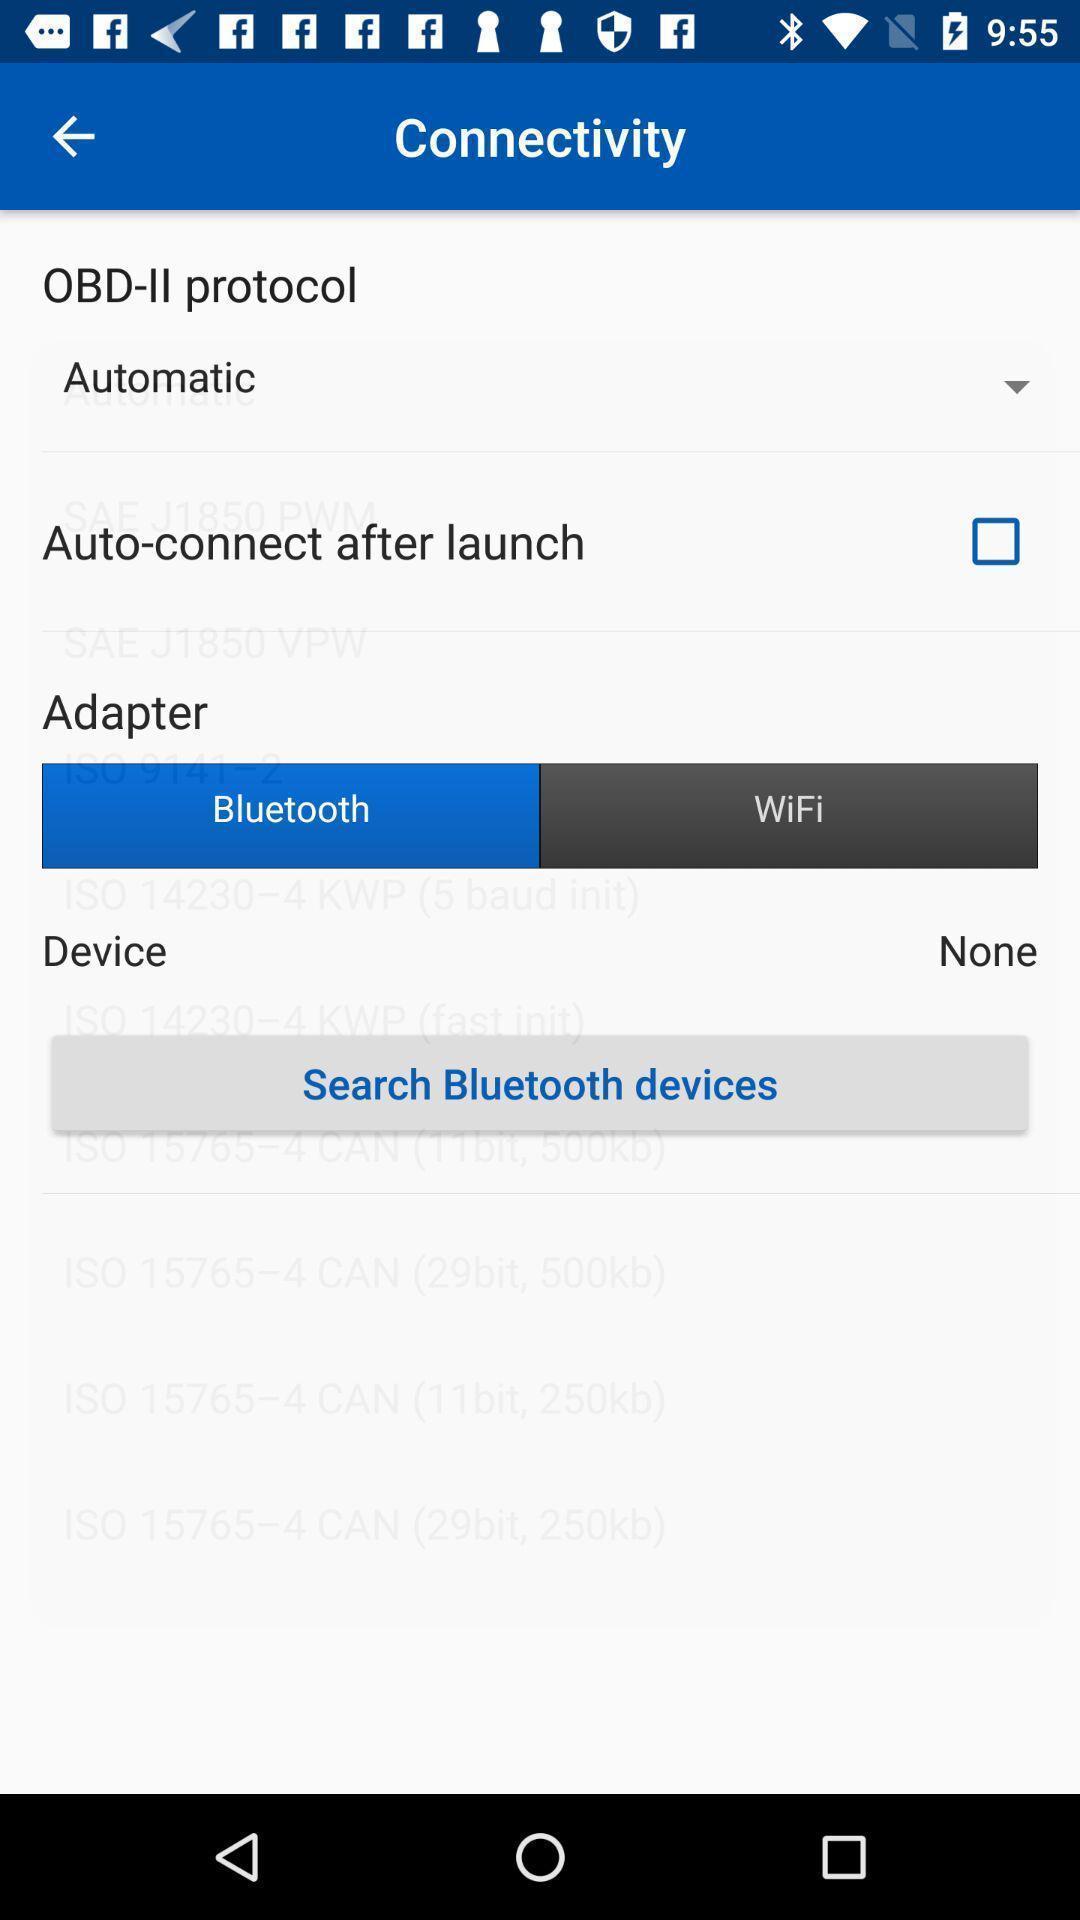Provide a detailed account of this screenshot. Page showing various options. 